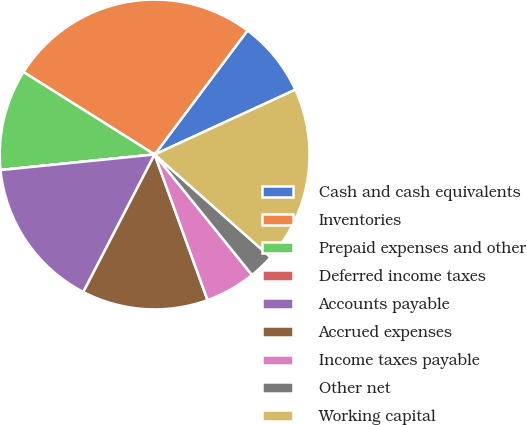<chart> <loc_0><loc_0><loc_500><loc_500><pie_chart><fcel>Cash and cash equivalents<fcel>Inventories<fcel>Prepaid expenses and other<fcel>Deferred income taxes<fcel>Accounts payable<fcel>Accrued expenses<fcel>Income taxes payable<fcel>Other net<fcel>Working capital<nl><fcel>7.9%<fcel>26.3%<fcel>10.53%<fcel>0.01%<fcel>15.78%<fcel>13.16%<fcel>5.27%<fcel>2.64%<fcel>18.41%<nl></chart> 